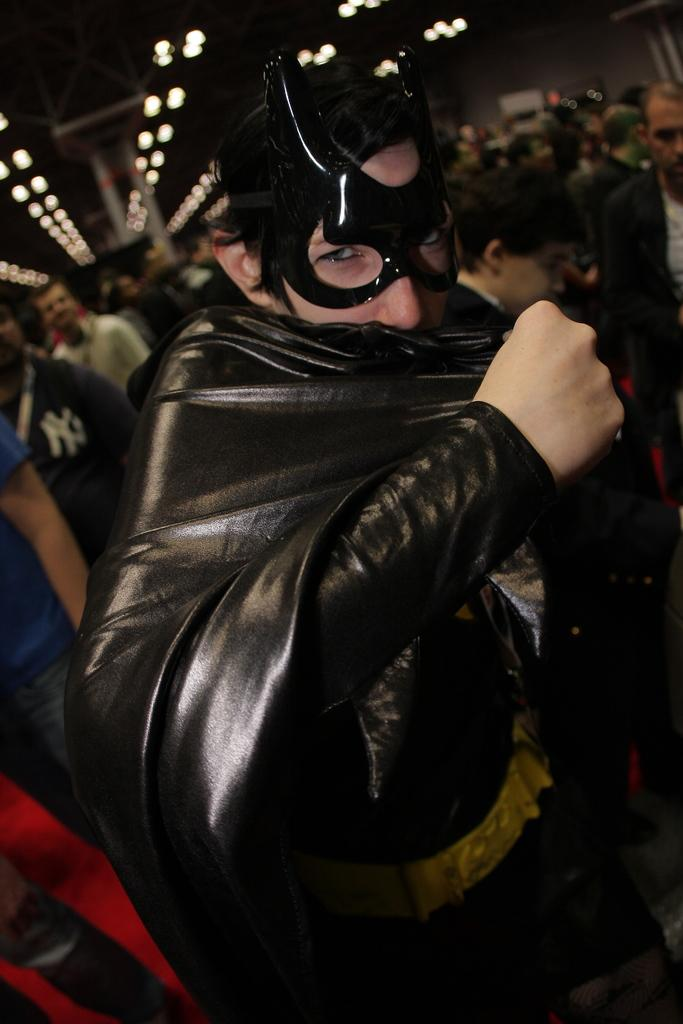What is the person in the foreground of the image wearing? The person in the foreground of the image is wearing a batman dress. Can you describe the people in the background of the image? There are other persons standing in the background of the image. What can be seen in the image besides the people? There are lights visible in the image. What type of zebra can be seen grazing in the background of the image? There is no zebra present in the image; it features a person wearing a batman dress and other people in the background. What material is the brass used for in the image? There is no brass present in the image. 